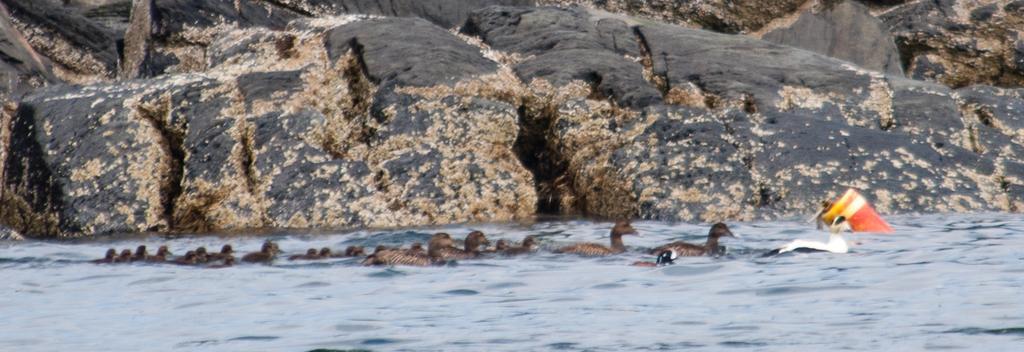Please provide a concise description of this image. In this picture I can see few rocks and few ducks and ducklings in the water and it looks like a bottle in the water. 